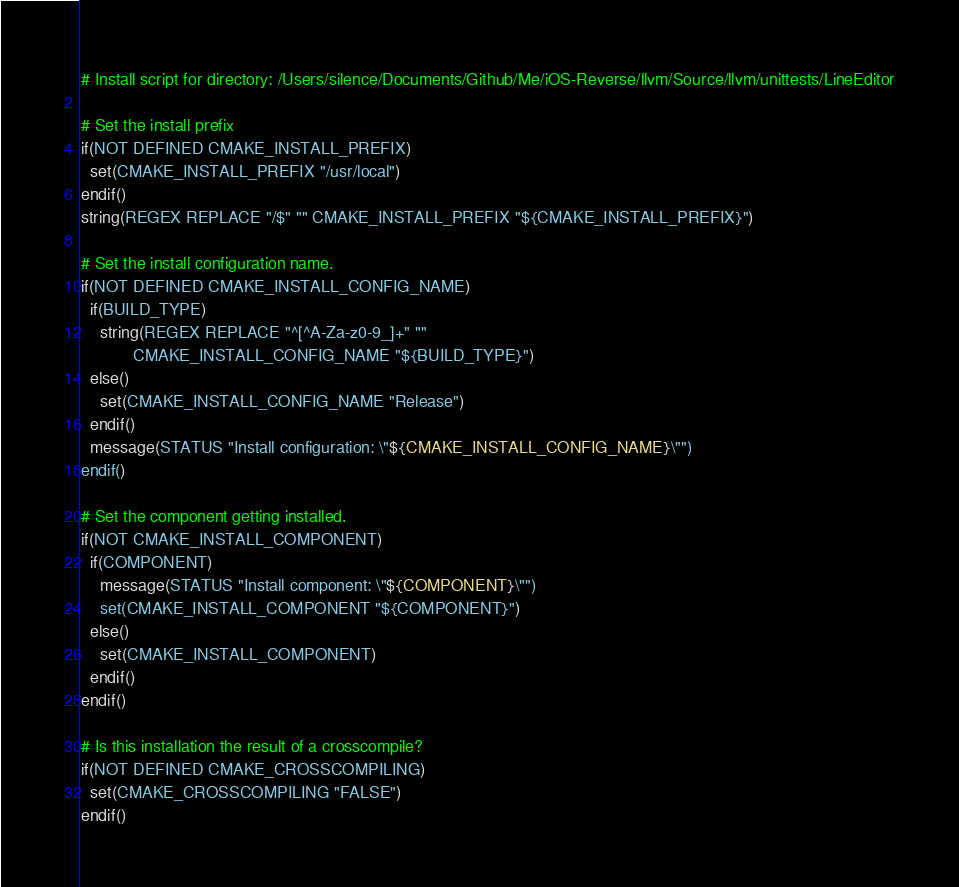<code> <loc_0><loc_0><loc_500><loc_500><_CMake_># Install script for directory: /Users/silence/Documents/Github/Me/iOS-Reverse/llvm/Source/llvm/unittests/LineEditor

# Set the install prefix
if(NOT DEFINED CMAKE_INSTALL_PREFIX)
  set(CMAKE_INSTALL_PREFIX "/usr/local")
endif()
string(REGEX REPLACE "/$" "" CMAKE_INSTALL_PREFIX "${CMAKE_INSTALL_PREFIX}")

# Set the install configuration name.
if(NOT DEFINED CMAKE_INSTALL_CONFIG_NAME)
  if(BUILD_TYPE)
    string(REGEX REPLACE "^[^A-Za-z0-9_]+" ""
           CMAKE_INSTALL_CONFIG_NAME "${BUILD_TYPE}")
  else()
    set(CMAKE_INSTALL_CONFIG_NAME "Release")
  endif()
  message(STATUS "Install configuration: \"${CMAKE_INSTALL_CONFIG_NAME}\"")
endif()

# Set the component getting installed.
if(NOT CMAKE_INSTALL_COMPONENT)
  if(COMPONENT)
    message(STATUS "Install component: \"${COMPONENT}\"")
    set(CMAKE_INSTALL_COMPONENT "${COMPONENT}")
  else()
    set(CMAKE_INSTALL_COMPONENT)
  endif()
endif()

# Is this installation the result of a crosscompile?
if(NOT DEFINED CMAKE_CROSSCOMPILING)
  set(CMAKE_CROSSCOMPILING "FALSE")
endif()

</code> 